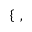<formula> <loc_0><loc_0><loc_500><loc_500>\left \{ \begin{array} { r l } \end{array} \, ,</formula> 